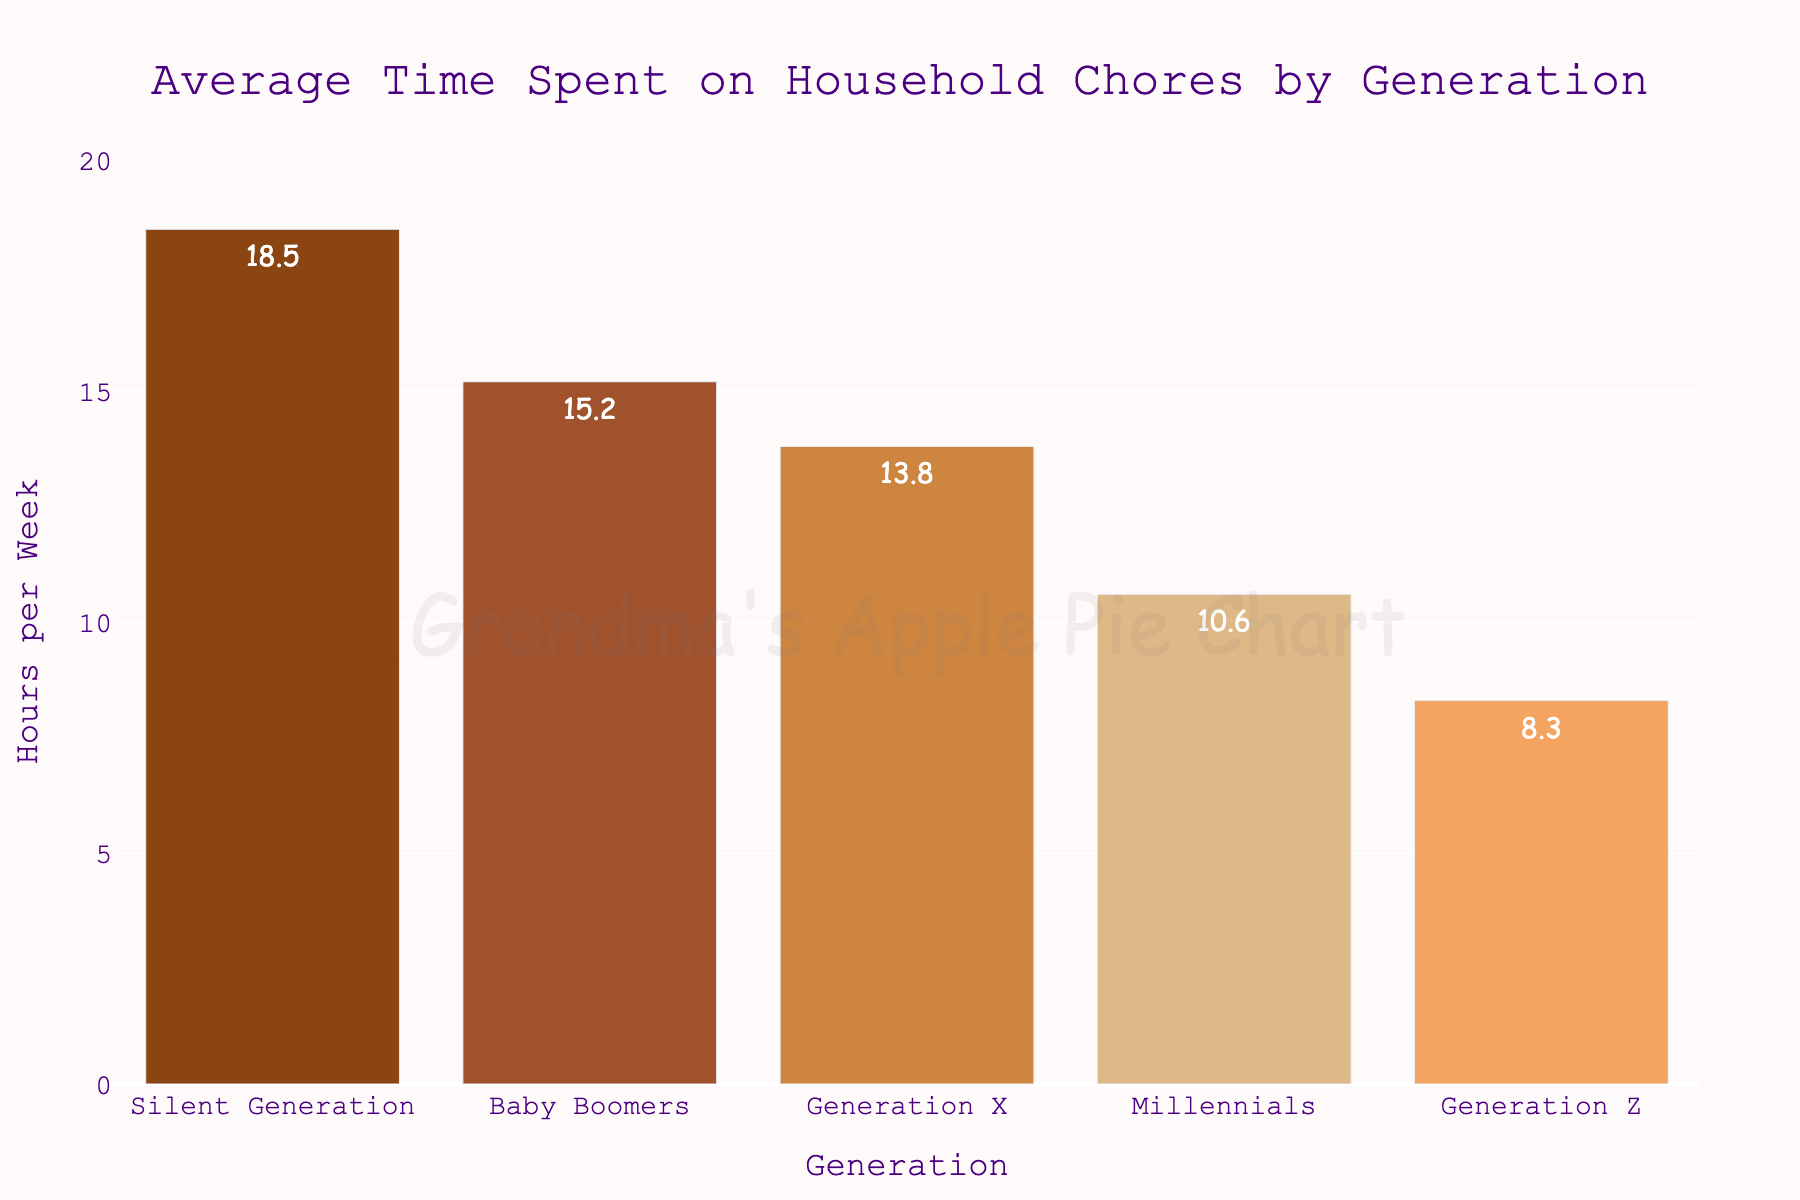What's the average time spent on household chores across all generations? First, add the average time spent on household chores for each generation: 18.5 (Silent Generation) + 15.2 (Baby Boomers) + 13.8 (Generation X) + 10.6 (Millennials) + 8.3 (Generation Z) = 66.4 hours. Next, divide by the number of generations (5). So the average is 66.4 / 5 = 13.28 hours.
Answer: 13.28 hours Which generation spends the least amount of time on household chores? The bar chart's shortest bar represents Generation Z, indicating they spend the least amount of time on household chores at 8.3 hours per week.
Answer: Generation Z How much more time does the Silent Generation spend on household chores compared to Generation Z? Subtract the time Generation Z spends on chores (8.3 hours) from the time the Silent Generation spends (18.5 hours): 18.5 - 8.3 = 10.2 hours.
Answer: 10.2 hours By how many hours does the average time spent on household chores decrease from Silent Generation to Baby Boomers? Subtract the average time spent by Baby Boomers (15.2 hours) from the time spent by the Silent Generation (18.5 hours): 18.5 - 15.2 = 3.3 hours.
Answer: 3.3 hours Which generation spends more time on household chores, Generation X or Millennials, and by how much? The average time spent by Generation X is 13.8 hours, and by Millennials is 10.6 hours. Subtract the Millennial value from Generation X: 13.8 - 10.6 = 3.2 hours. Generation X spends more time.
Answer: Generation X, 3.2 hours Rank the generations in order from those who spend the most time on chores to the least. By comparing the heights of the bars, the ranking is as follows: Silent Generation (18.5 hours), Baby Boomers (15.2 hours), Generation X (13.8 hours), Millennials (10.6 hours), and Generation Z (8.3 hours).
Answer: Silent Generation, Baby Boomers, Generation X, Millennials, Generation Z What is the total time spent on household chores by Baby Boomers and Millennials combined? Add the time spent by Baby Boomers (15.2 hours) and Millennials (10.6 hours): 15.2 + 10.6 = 25.8 hours.
Answer: 25.8 hours Visualize the difference between Baby Boomers and Generation Z in terms of the color of their bars. What colors represent these generations? The colors of the bars visually represent the generations: Baby Boomers are shown with a medium brown color, while Generation Z is depicted with a light orange color.
Answer: Medium brown (Baby Boomers), Light orange (Generation Z) 